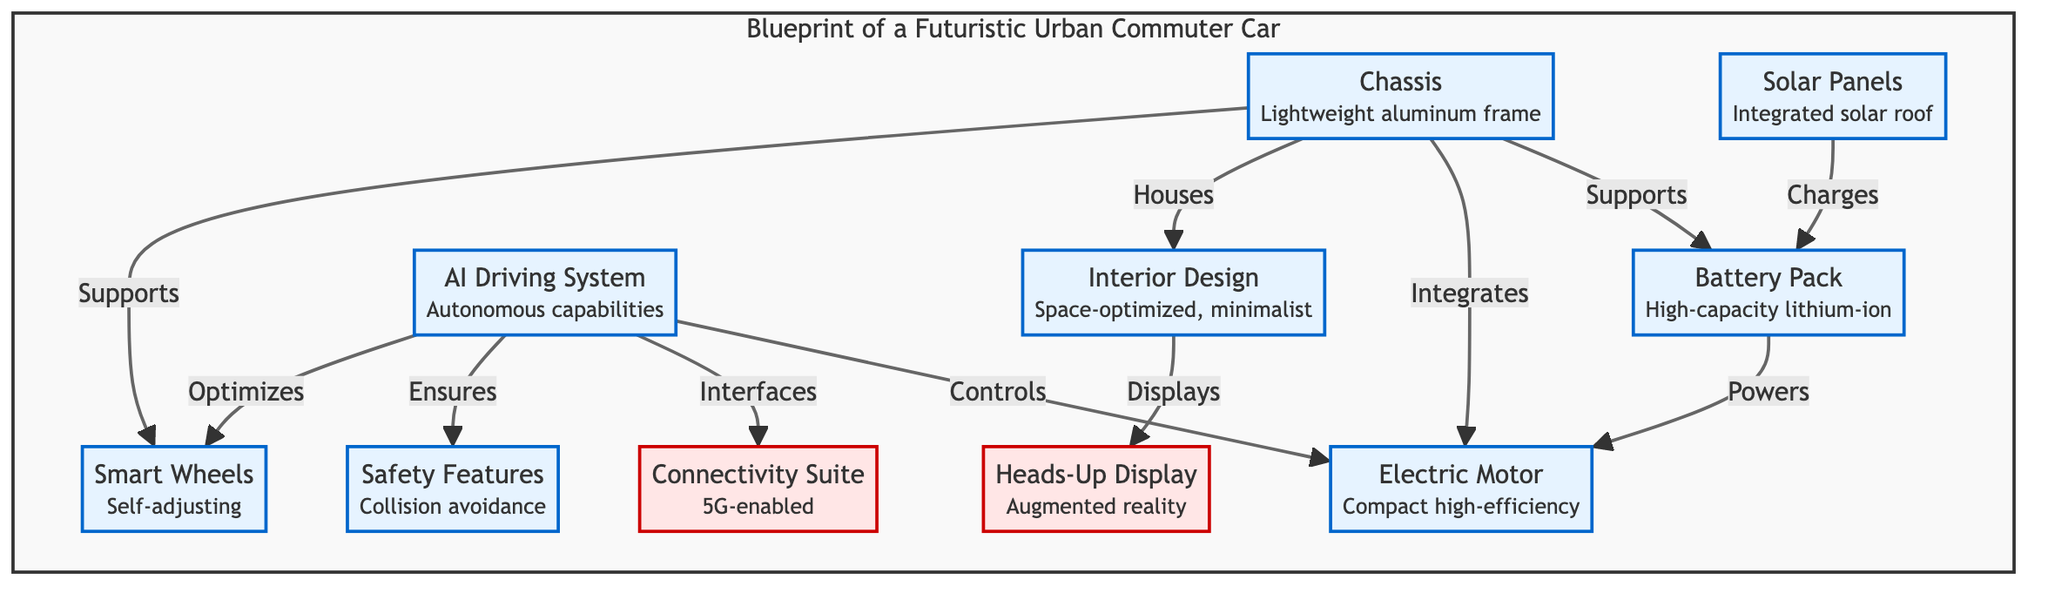What is the material of the chassis? The diagram specifies that the chassis is made of "Lightweight aluminum frame," highlighting its design to potentially enhance performance and reduce weight.
Answer: Lightweight aluminum frame How many main components are highlighted in the blueprint? Counting the components listed in the diagram, there are a total of 8 components: chassis, battery pack, electric motor, AI driving system, solar panels, interior design, safety features, and smart wheels.
Answer: 8 What feature does the AI Driving System ensure? The AI Driving System is linked to "Safety Features" and is responsible for ensuring collision avoidance, as indicated in the connections drawn in the diagram.
Answer: Collision avoidance Which component has the function of charging the battery? The diagram indicates that the "Solar Panels" are responsible for charging the battery pack, showing a direct connection from solar panels to battery.
Answer: Solar Panels What innovative system does the interior design display? The "Heads-Up Display" utilizes augmented reality to share information from the interior design, as shown by the connection linking interior design to HUD.
Answer: Augmented reality How does the electric motor receive power? According to the flow in the diagram, the battery pack directly powers the electric motor, demonstrating a direct functional relationship in the design.
Answer: Powers What type of wheels are used in this futuristic car? The diagram identifies the wheels as "Smart Wheels," which are designed for self-adjusting, indicating an advanced feature for adaptability.
Answer: Smart Wheels How does the AI Driving System interact with the connectivity suite? The AI Driving System interfaces directly with the connectivity suite, which is 5G-enabled, showing a focus on modern communication capabilities in the vehicle’s design.
Answer: Interfaces What type of battery is used in the vehicle? The vehicle utilizes a "High-capacity lithium-ion" battery pack, which is noted in the diagram as a key component of the car's energy system.
Answer: High-capacity lithium-ion 